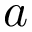<formula> <loc_0><loc_0><loc_500><loc_500>a</formula> 